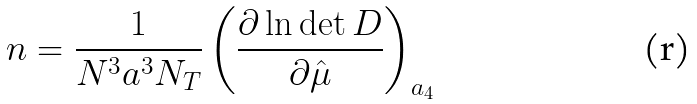Convert formula to latex. <formula><loc_0><loc_0><loc_500><loc_500>n = \frac { 1 } { N ^ { 3 } a ^ { 3 } N _ { T } } \left ( \frac { \partial \ln \det D } { \partial \hat { \mu } } \right ) _ { a _ { 4 } }</formula> 